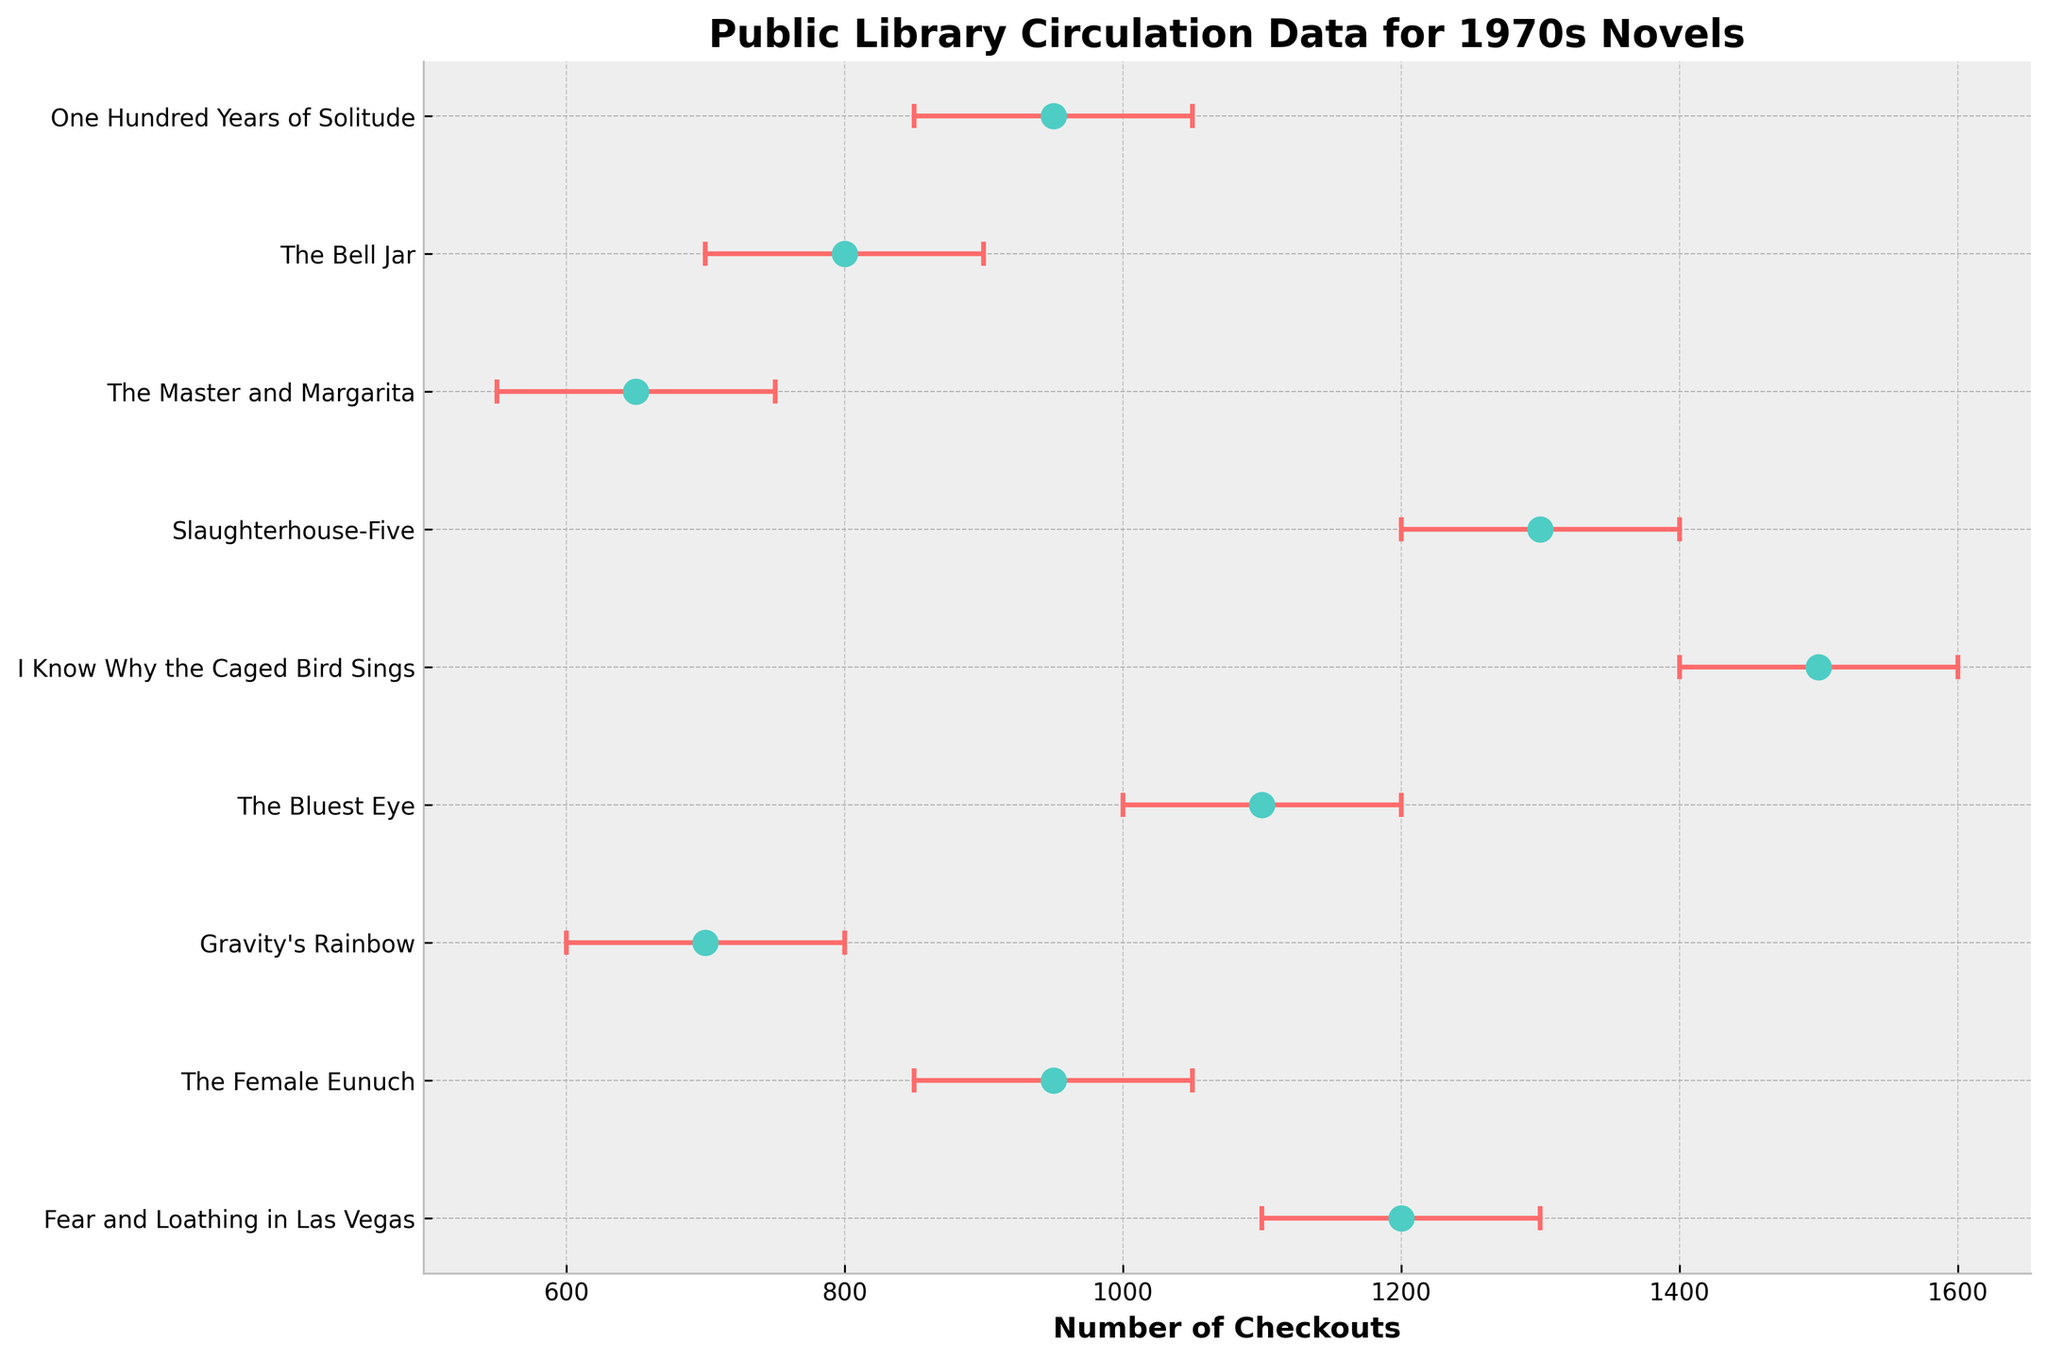what is the title of the figure? The title is usually found at the top of the figure, and in this case, it provides context for the data being displayed. Here, the title clearly states the focus: "Public Library Circulation Data for 1970s Novels".
Answer: Public Library Circulation Data for 1970s Novels which novel has the highest mean checkouts? To find the novel with the highest mean checkouts, scan the x-axis for the largest mean value and identify the corresponding title on the y-axis. "I Know Why the Caged Bird Sings" by Maya Angelou has the highest mean checkouts of 1500.
Answer: I Know Why the Caged Bird Sings how many novels have a mean checkouts value greater than 1000? Count the number of data points (dots) to the right of the 1000 mark on the x-axis. There are four novels with mean checkouts greater than 1000.
Answer: 4 which novels have an uncertainty range that overlaps with "Gravity’s Rainbow"? Check the error bars for "Gravity’s Rainbow", which ranges from 600 to 800, then see which other novels have error bars that overlap this range. Both "The Female Eunuch" and "The Bell Jar" have overlapping ranges.
Answer: The Female Eunuch, The Bell Jar what is the range of uncertainty for "Slaughterhouse-Five"? The uncertainty range is represented by the error bars on either side of the mean value. For "Slaughterhouse-Five", the range is given as 1200 to 1400. The span, 1400 - 1200, is 200.
Answer: 200 is the mean checkout number for "Gravity’s Rainbow" less than that for "The Bluest Eye"? Compare the mean values directly by looking at their respective dots on the x-axis. "Gravity’s Rainbow" has a mean of 700, while "The Bluest Eye" has a mean of 1100.
Answer: Yes what novel is checked out more frequently in New York Public Library compared to a novel checked out in Seattle Public Library? Cross-reference each novel’s title with its corresponding library. "Fear and Loathing in Las Vegas" (New York) has 1200 checkouts, while "Slaughterhouse-Five" (Seattle) has 1300 checkouts. None have more in New York.
Answer: None which novel has the smallest range of uncertainty? The smallest range of uncertainty can be found by identifying the shortest error bar. "The Bell Jar" has the smallest range of uncertainty (900 - 700 = 200).
Answer: The Bell Jar which novel at the Los Angeles Public Library has the lowest mean checkouts? Identify and compare the mean checkouts for novels categorized under the Los Angeles Public Library. "The Female Eunuch" has a mean of 950, the only one from Los Angeles, thus the lowest.
Answer: The Female Eunuch 